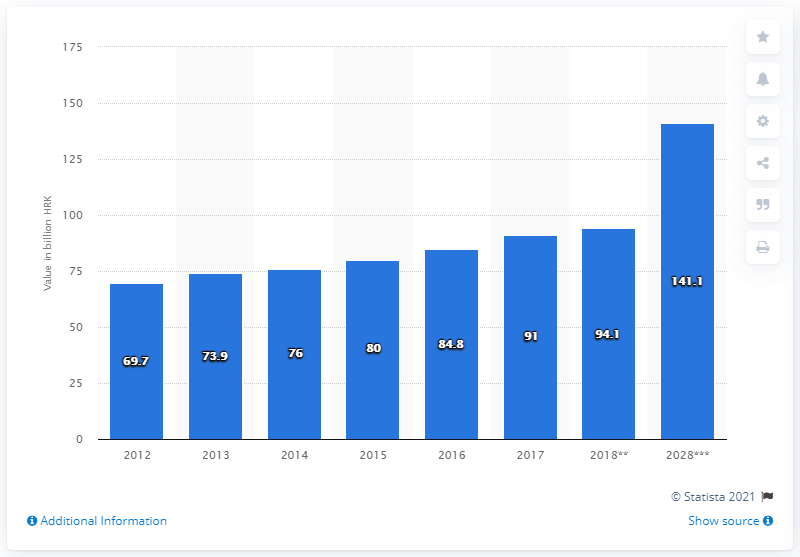Specify some key components in this picture. The travel and tourism industry in Croatia contributed approximately 91% of its Gross Domestic Product (GDP) in 2017. 